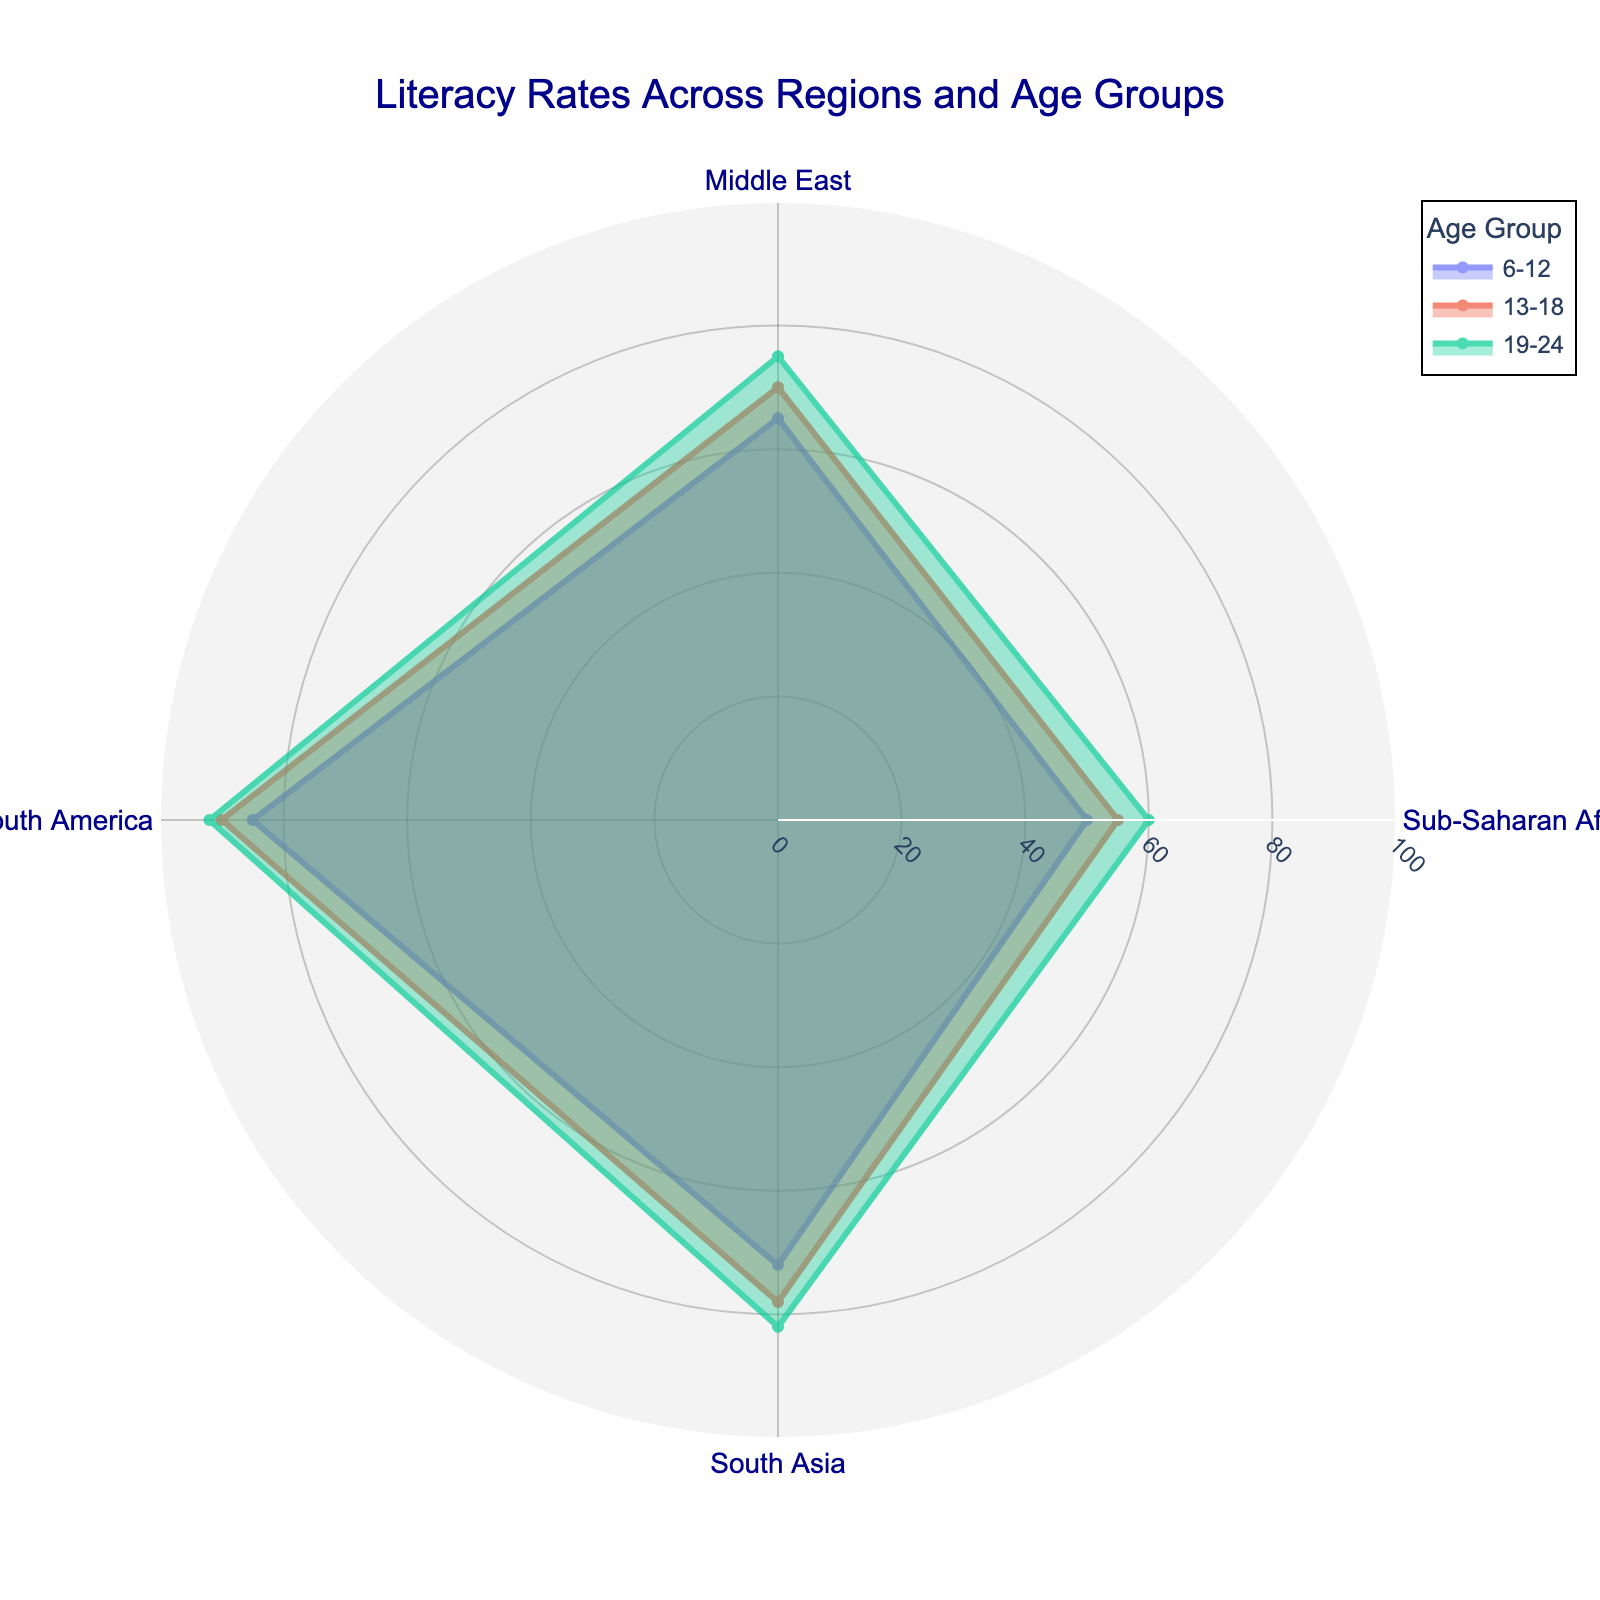What's the title of the figure? The title is usually placed at the top of the figure in a larger and bolder font. Reading it directly from the top center of the chart provides the answer.
Answer: Literacy Rates Across Regions and Age Groups Which region has the highest literacy rate for the 13-18 age group? To answer this, look at the section of the polar chart corresponding to the 13-18 age group and identify the highest point among the regions.
Answer: South America What's the average literacy rate for South Asia across all age groups? Sum the literacy rates for South Asia (72 + 78 + 82) and then divide by the number of age groups (3) to find the average. Calculation: (72 + 78 + 82) / 3 = 77.3
Answer: 77.3 Which age group shows the most improvement in literacy rate in the Middle East? Compare the three data points for the Middle East across the 6-12, 13-18, and 19-24 age groups and identify the age group that shows the largest increase.
Answer: 19-24 How does the literacy rate for the 6-12 age group in Sub-Saharan Africa compare to the 19-24 age group in the same region? Compare the points for Sub-Saharan Africa in the 6-12 (50%) and 19-24 (60%) age groups. Note which one is higher.
Answer: The 19-24 age group has a higher literacy rate What is the total literacy rate for all age groups in South America? Add up the literacy rates for South America across all age groups (85 + 90 + 92). Calculation: 85 + 90 + 92 = 267
Answer: 267 Which age group has the smallest range of literacy rates across all regions? Calculate the range for each age group by subtracting the smallest literacy rate from the largest, then compare these ranges. The ranges are as follows: (85-50) = 35 for 6-12, (90-55) = 35 for 13-18, and (92-60) = 32 for 19-24.
Answer: 19-24 Which region shows the least variation in literacy rates across different age groups? Calculate the difference between the highest and lowest literacy rates for each region and identify the smallest difference. Middle East (75-65) = 10, Sub-Saharan Africa (60-50) = 10, South Asia (82-72) = 10, South America (92-85) = 7.
Answer: South America 